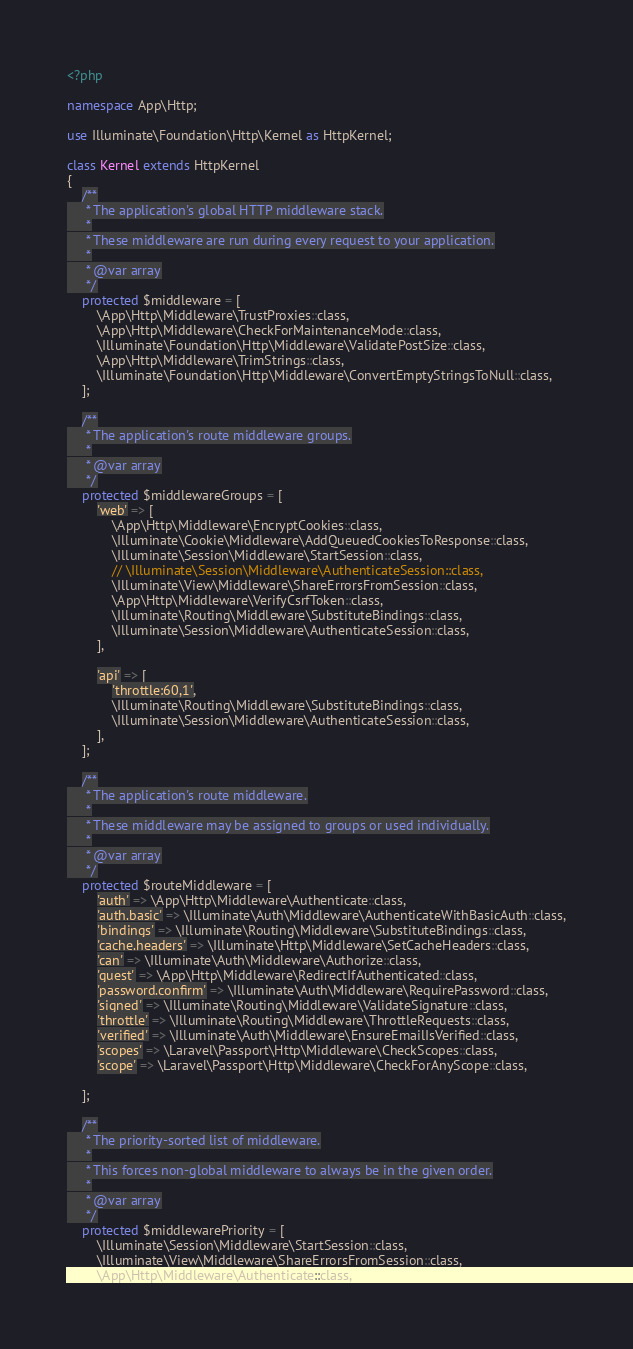<code> <loc_0><loc_0><loc_500><loc_500><_PHP_><?php

namespace App\Http;

use Illuminate\Foundation\Http\Kernel as HttpKernel;

class Kernel extends HttpKernel
{
    /**
     * The application's global HTTP middleware stack.
     *
     * These middleware are run during every request to your application.
     *
     * @var array
     */
    protected $middleware = [
        \App\Http\Middleware\TrustProxies::class,
        \App\Http\Middleware\CheckForMaintenanceMode::class,
        \Illuminate\Foundation\Http\Middleware\ValidatePostSize::class,
        \App\Http\Middleware\TrimStrings::class,
        \Illuminate\Foundation\Http\Middleware\ConvertEmptyStringsToNull::class,
    ];

    /**
     * The application's route middleware groups.
     *
     * @var array
     */
    protected $middlewareGroups = [
        'web' => [
            \App\Http\Middleware\EncryptCookies::class,
            \Illuminate\Cookie\Middleware\AddQueuedCookiesToResponse::class,
            \Illuminate\Session\Middleware\StartSession::class,
            // \Illuminate\Session\Middleware\AuthenticateSession::class,
            \Illuminate\View\Middleware\ShareErrorsFromSession::class,
            \App\Http\Middleware\VerifyCsrfToken::class,
            \Illuminate\Routing\Middleware\SubstituteBindings::class,
            \Illuminate\Session\Middleware\AuthenticateSession::class,
        ],

        'api' => [
            'throttle:60,1',
            \Illuminate\Routing\Middleware\SubstituteBindings::class,
            \Illuminate\Session\Middleware\AuthenticateSession::class,
        ],
    ];

    /**
     * The application's route middleware.
     *
     * These middleware may be assigned to groups or used individually.
     *
     * @var array
     */
    protected $routeMiddleware = [
        'auth' => \App\Http\Middleware\Authenticate::class,
        'auth.basic' => \Illuminate\Auth\Middleware\AuthenticateWithBasicAuth::class,
        'bindings' => \Illuminate\Routing\Middleware\SubstituteBindings::class,
        'cache.headers' => \Illuminate\Http\Middleware\SetCacheHeaders::class,
        'can' => \Illuminate\Auth\Middleware\Authorize::class,
        'guest' => \App\Http\Middleware\RedirectIfAuthenticated::class,
        'password.confirm' => \Illuminate\Auth\Middleware\RequirePassword::class,
        'signed' => \Illuminate\Routing\Middleware\ValidateSignature::class,
        'throttle' => \Illuminate\Routing\Middleware\ThrottleRequests::class,
        'verified' => \Illuminate\Auth\Middleware\EnsureEmailIsVerified::class,
        'scopes' => \Laravel\Passport\Http\Middleware\CheckScopes::class,
        'scope' => \Laravel\Passport\Http\Middleware\CheckForAnyScope::class,

    ];

    /**
     * The priority-sorted list of middleware.
     *
     * This forces non-global middleware to always be in the given order.
     *
     * @var array
     */
    protected $middlewarePriority = [
        \Illuminate\Session\Middleware\StartSession::class,
        \Illuminate\View\Middleware\ShareErrorsFromSession::class,
        \App\Http\Middleware\Authenticate::class,</code> 